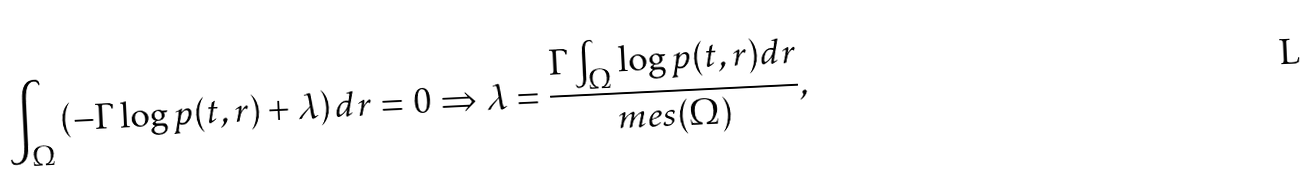<formula> <loc_0><loc_0><loc_500><loc_500>\int _ { \Omega } { \left ( - \Gamma \log { p ( t , r ) } + \lambda \right ) d r } = 0 \Rightarrow \lambda = \frac { \Gamma \int _ { \Omega } \log { p ( t , r ) d r } } { m e s ( \Omega ) } ,</formula> 